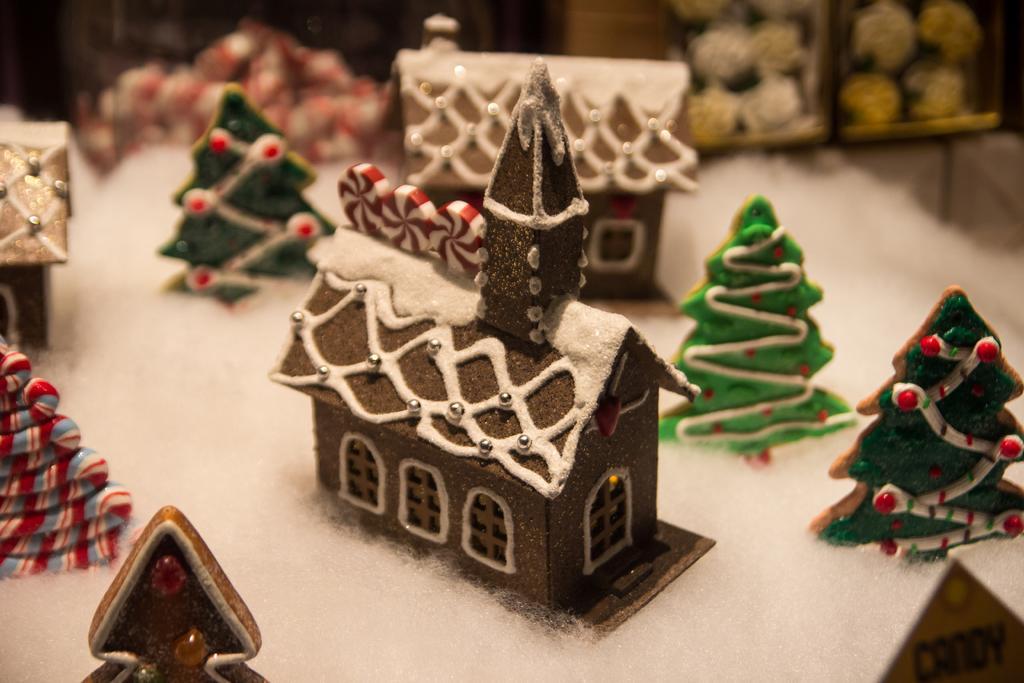Can you describe this image briefly? In the image there are small cardboard trees all around tiny homes on the snow. 